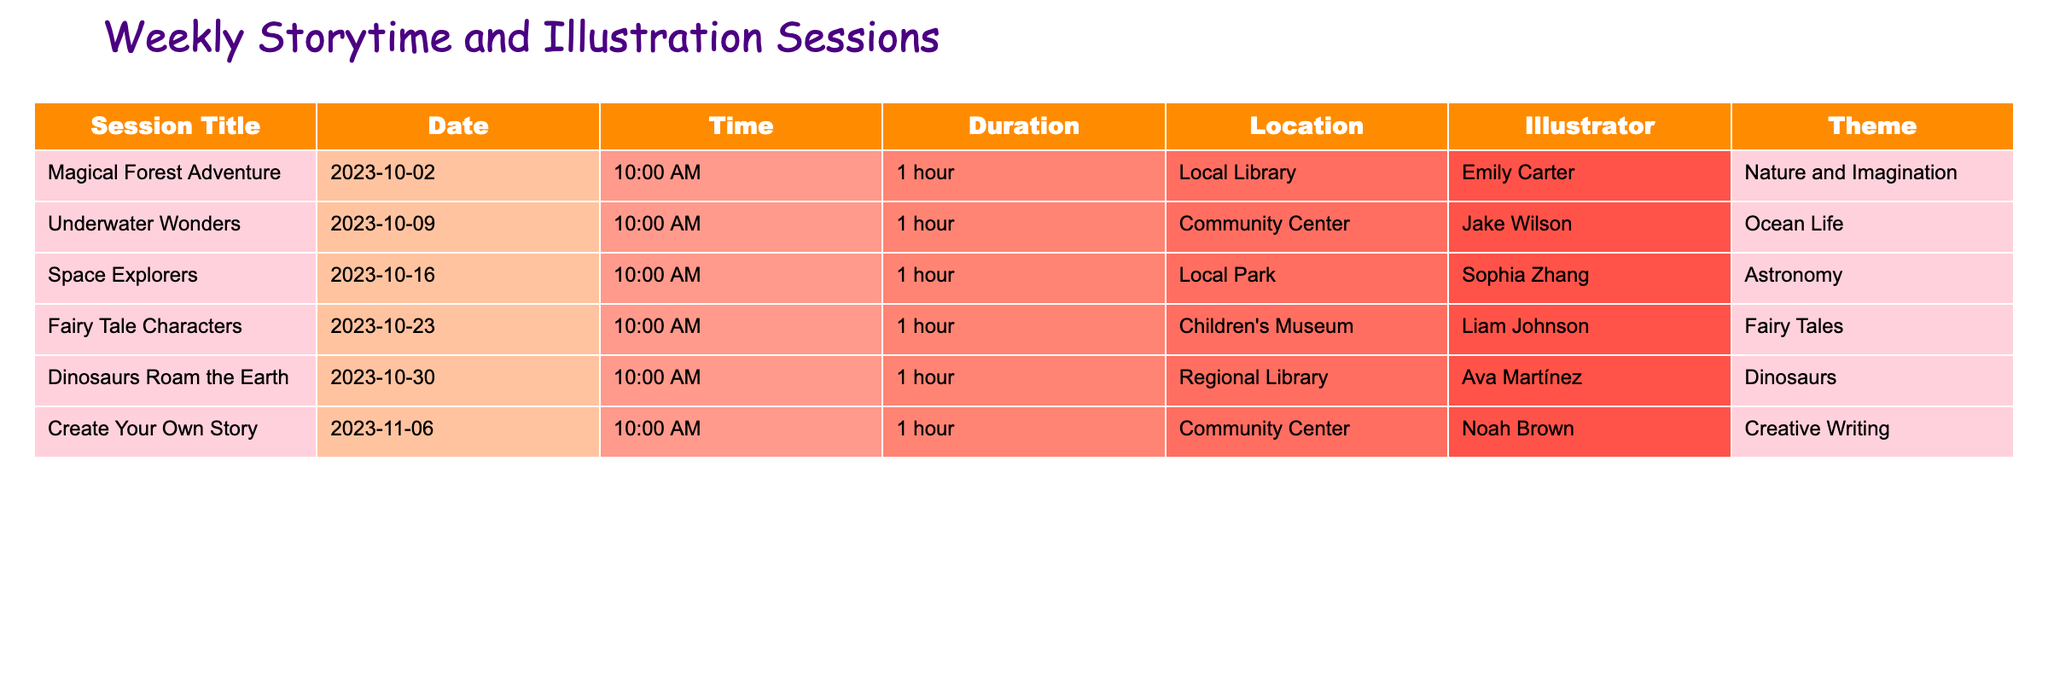What is the theme of the "Space Explorers" session? The theme is listed in the table next to the session title for "Space Explorers," which is Astronomy.
Answer: Astronomy How many sessions are held at the Local Library? By reviewing the Location column, we see that "Magical Forest Adventure" and "Dinosaurs Roam the Earth" are both held at the Local Library. There are 2 sessions in total.
Answer: 2 Which illustrator is featured in the "Underwater Wonders" session? The illustrator for "Underwater Wonders" is found in the corresponding column of the table, which shows Jake Wilson as the assigned illustrator.
Answer: Jake Wilson On what date is the "Create Your Own Story" session scheduled? The table specifies that the session "Create Your Own Story" is scheduled for November 6, 2023.
Answer: 2023-11-06 What is the total number of sessions happening in October 2023? There are five sessions listed in the table for October, specifically from October 2 to October 30. Therefore, the total number of sessions is 5.
Answer: 5 Is there a session that features dinosaurs, and if so, what date is it scheduled? Referencing the table, "Dinosaurs Roam the Earth" is indeed a session featuring dinosaurs, scheduled for October 30, 2023.
Answer: Yes, 2023-10-30 What is the duration of each session, and is the duration the same for all? All sessions have a duration of 1 hour according to the Duration column in the table, indicating uniformity across all the scheduled events.
Answer: Yes, 1 hour Which session has the theme "Fairy Tales" and what date is it on? The session that includes "Fairy Tales" as its theme is "Fairy Tale Characters." Referring to the table, it is scheduled for October 23, 2023.
Answer: Fairy Tale Characters, 2023-10-23 If I attend all the sessions in October, how many hours will I have spent in total? There are 5 sessions in October, each lasting 1 hour. Multiplying the number of sessions (5) by the duration (1 hour each) gives 5 hours total.
Answer: 5 hours 